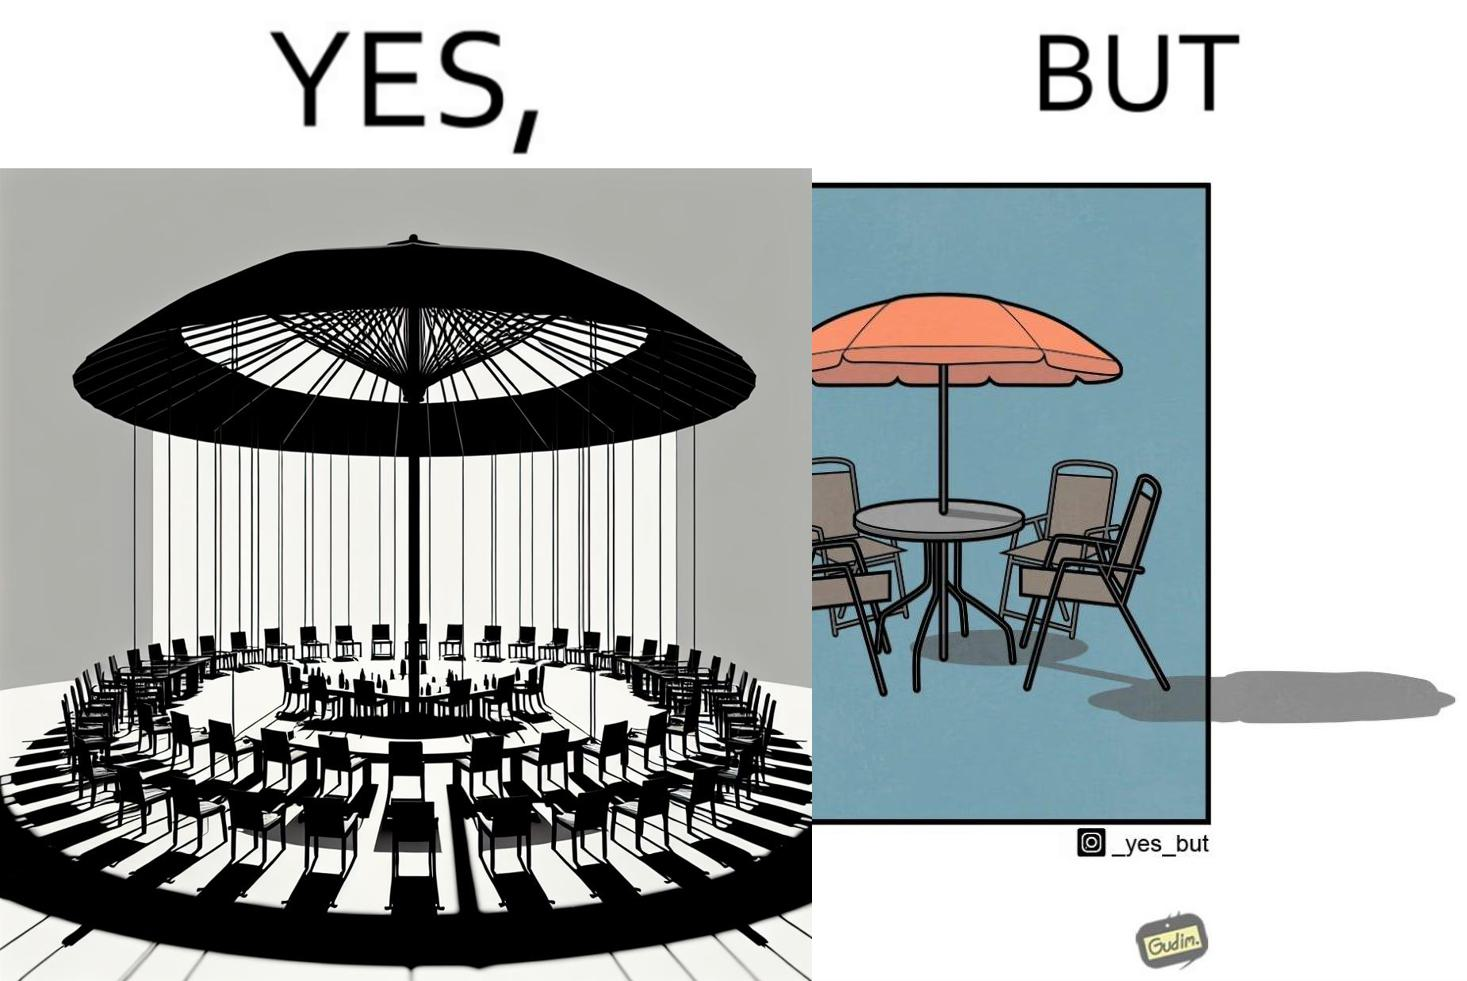Describe the content of this image. The image is ironical, as the umbrella is meant to provide shadow in the area where the chairs are present, but due to the orientation of the rays of the sun, all the chairs are in sunlight, and the umbrella is of no use in this situation. 